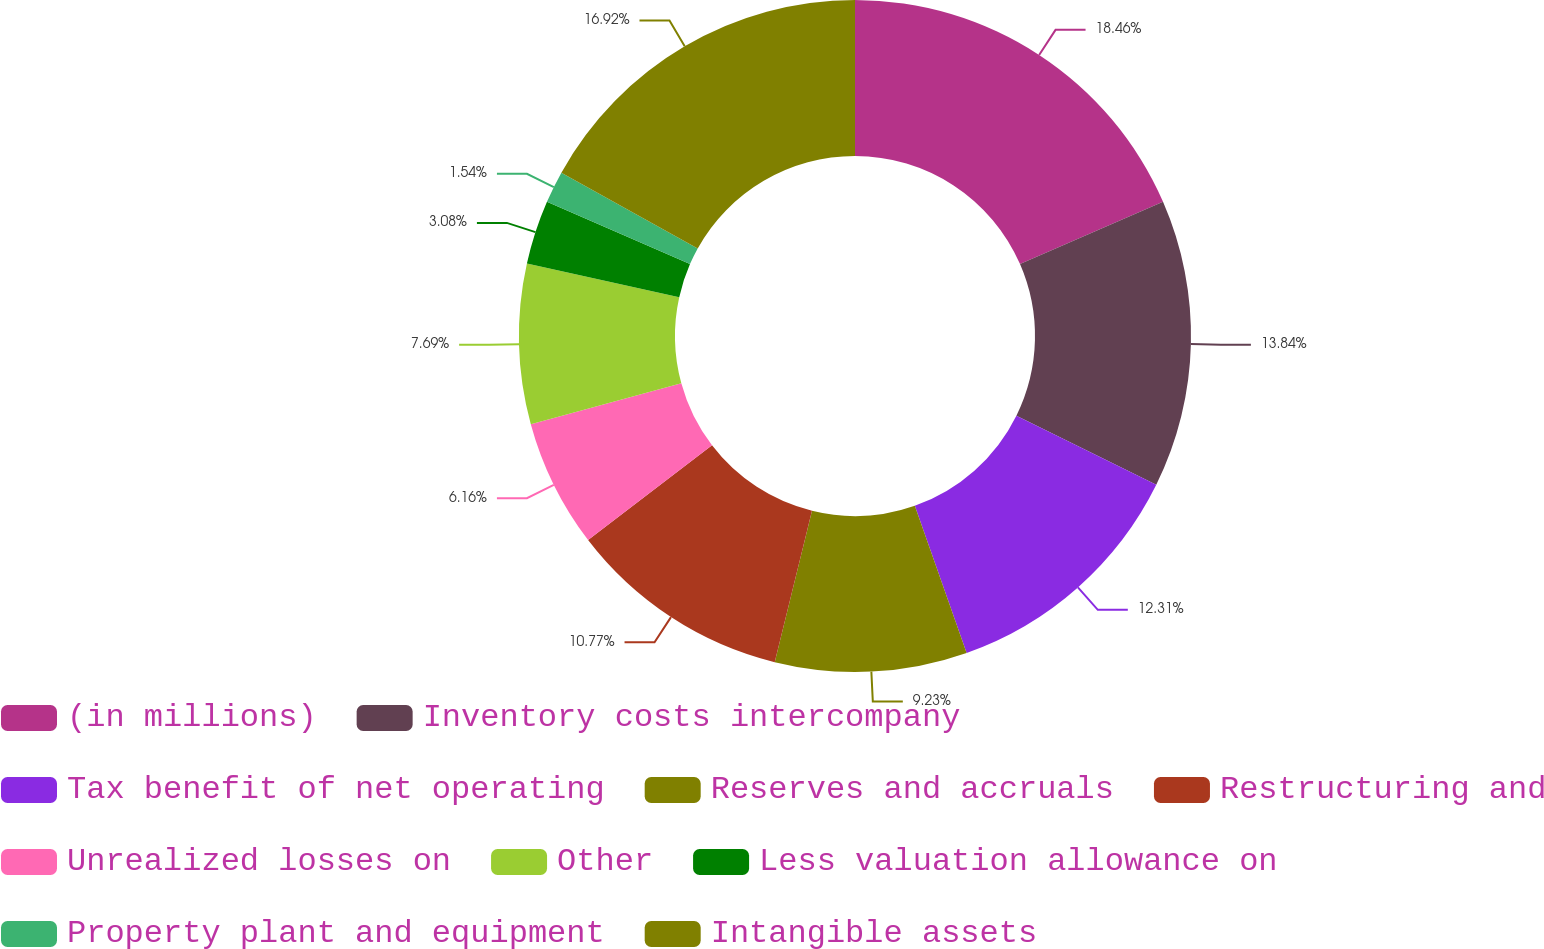<chart> <loc_0><loc_0><loc_500><loc_500><pie_chart><fcel>(in millions)<fcel>Inventory costs intercompany<fcel>Tax benefit of net operating<fcel>Reserves and accruals<fcel>Restructuring and<fcel>Unrealized losses on<fcel>Other<fcel>Less valuation allowance on<fcel>Property plant and equipment<fcel>Intangible assets<nl><fcel>18.46%<fcel>13.84%<fcel>12.31%<fcel>9.23%<fcel>10.77%<fcel>6.16%<fcel>7.69%<fcel>3.08%<fcel>1.54%<fcel>16.92%<nl></chart> 